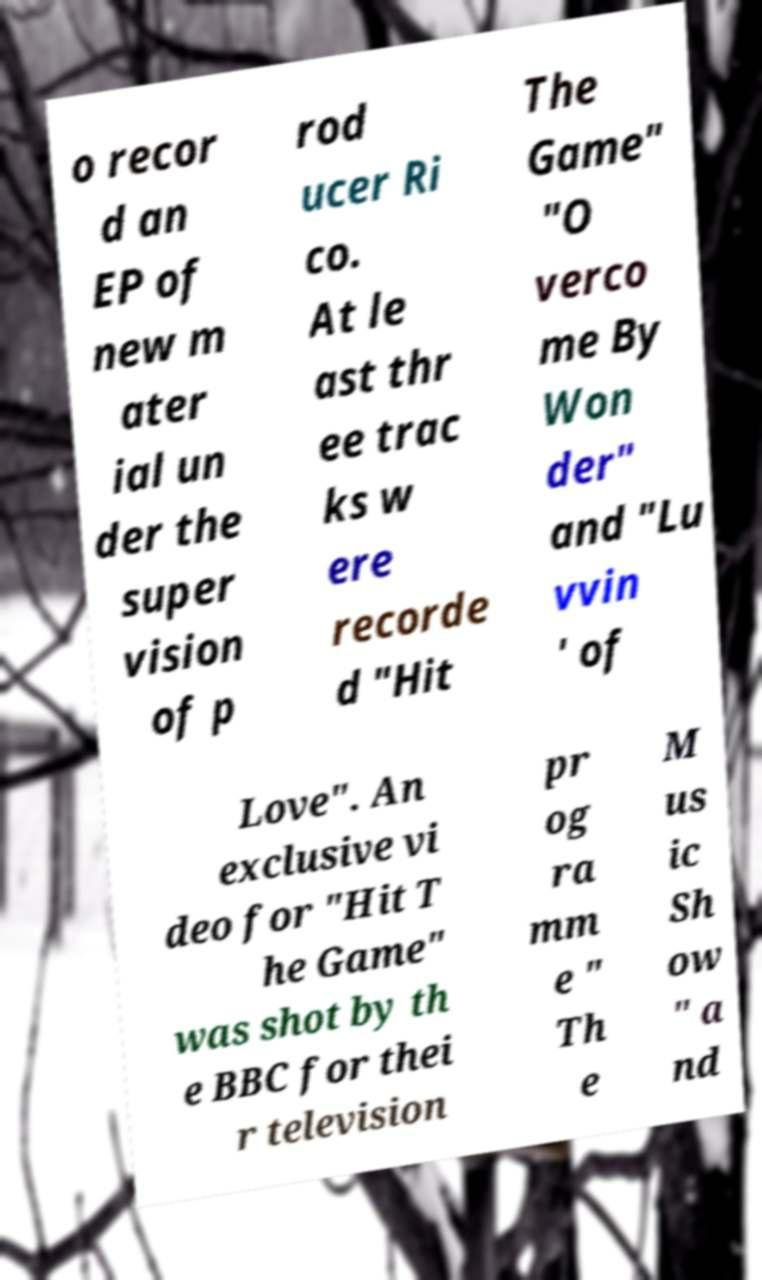Please identify and transcribe the text found in this image. o recor d an EP of new m ater ial un der the super vision of p rod ucer Ri co. At le ast thr ee trac ks w ere recorde d "Hit The Game" "O verco me By Won der" and "Lu vvin ' of Love". An exclusive vi deo for "Hit T he Game" was shot by th e BBC for thei r television pr og ra mm e " Th e M us ic Sh ow " a nd 